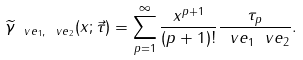<formula> <loc_0><loc_0><loc_500><loc_500>\widetilde { \gamma } _ { \ v e _ { 1 } , \ v e _ { 2 } } ( x ; \vec { \tau } ) = \sum _ { p = 1 } ^ { \infty } \frac { x ^ { p + 1 } } { ( p + 1 ) ! } \frac { \tau _ { p } } { \ v e _ { 1 } \ v e _ { 2 } } .</formula> 